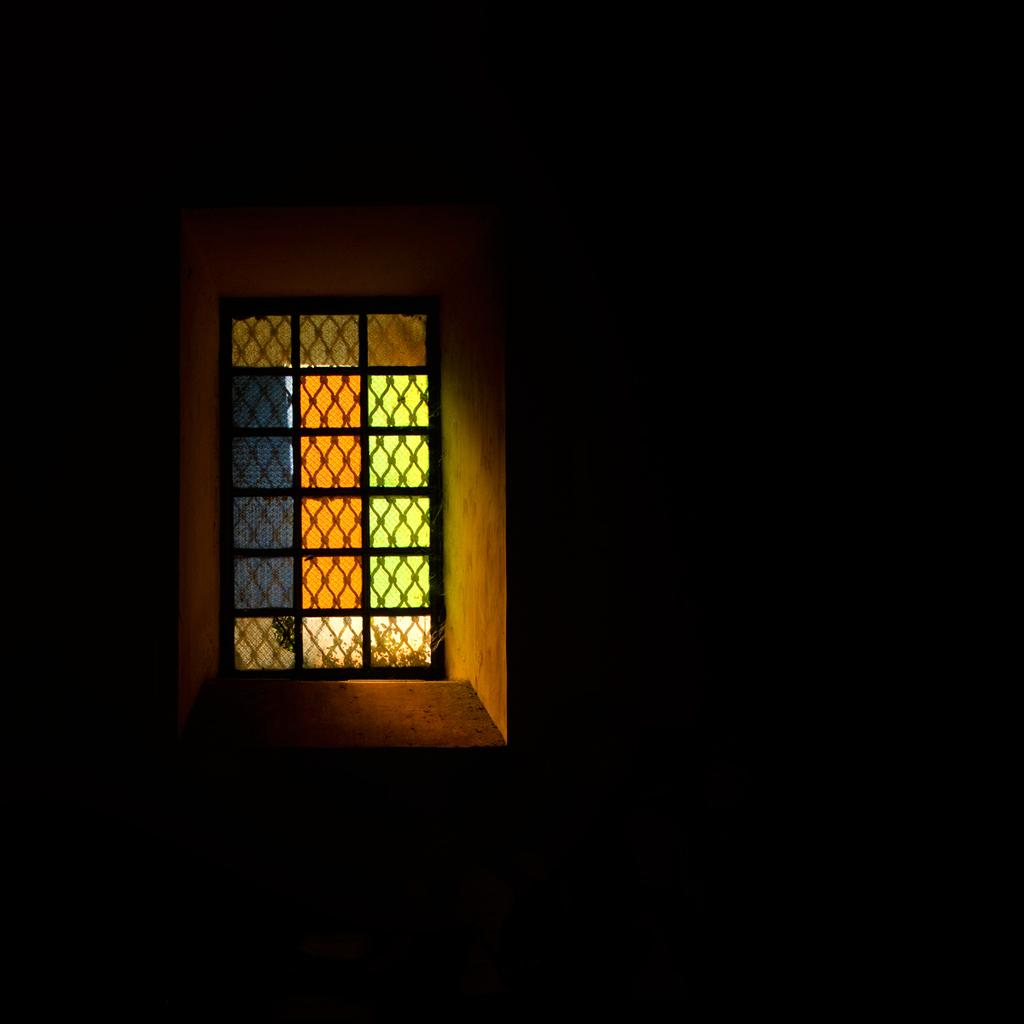What can be seen in the image that provides a view of the outside? There is a window in the image. What is the color or appearance of the area around the window? The surface around the window is dark. What type of chalk is being used to draw on the window in the image? There is no chalk or drawing present on the window in the image. 